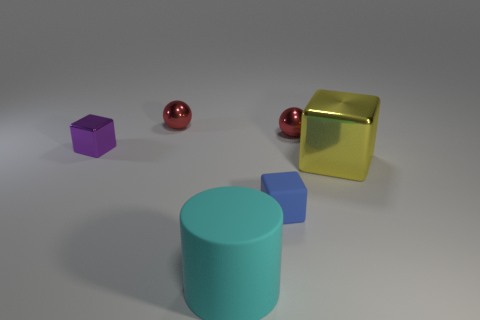Do the large yellow metallic object and the large matte object have the same shape? The large yellow metallic object and the large matte object differ in shape. The yellow object is a cube, which has six square faces of equal size, while the large matte object appears to be a cylinder, characterized by its circular top and curved surface. 